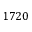<formula> <loc_0><loc_0><loc_500><loc_500>1 7 2 0</formula> 